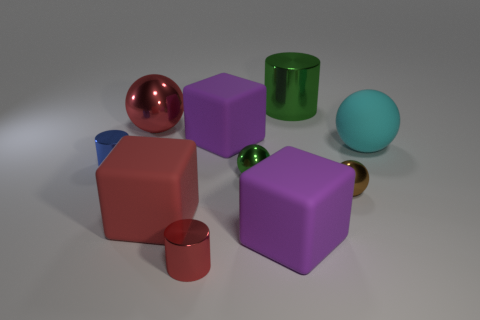What shapes are present in the image? The image includes a variety of geometric shapes: there are cubes, spheres, a cylinder, and what looks like a truncated cone. 